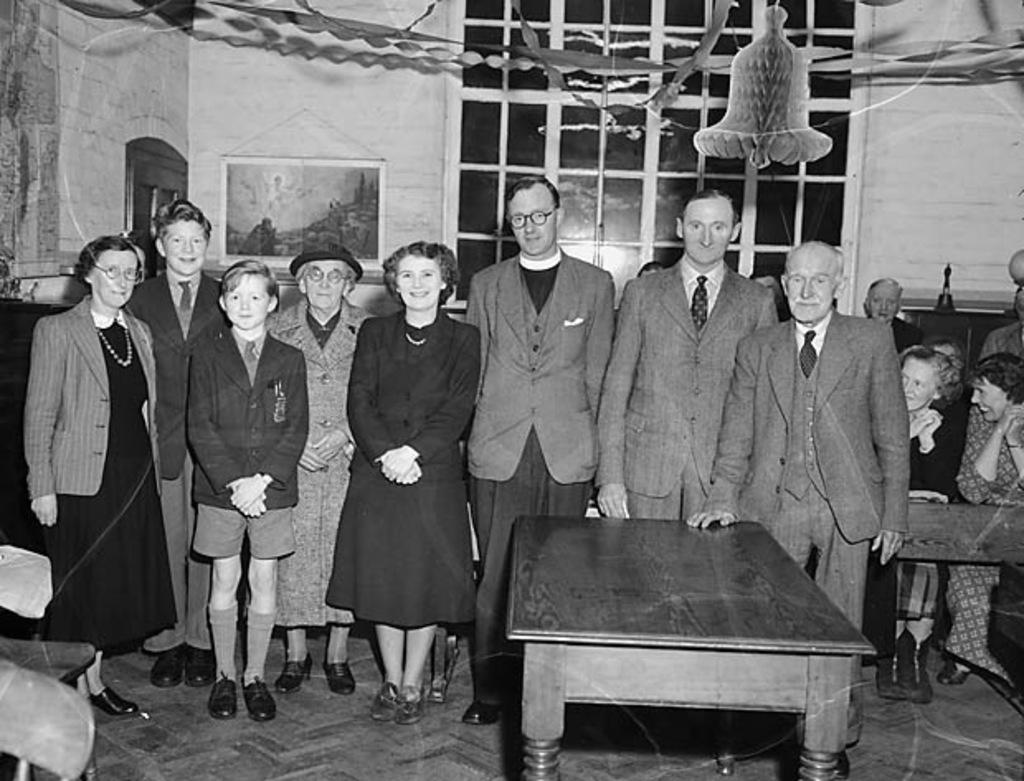What is the color scheme of the image? The image is black and white. Who or what can be seen in the image? There are people in the image. What piece of furniture is present in the image? There is a table in the image. What other objects are present in the image besides the people and table? There are other objects present in the image, but their specific details are not mentioned in the facts. What can be seen in the background of the image? There is a wall, a window, and a frame in the background of the image. Are there any objects visible in the background of the image? Yes, there are objects visible in the background of the image. What year does the image depict the harmony between the parent and child? The image does not depict a specific year, and there is no mention of a parent or child in the facts provided. 